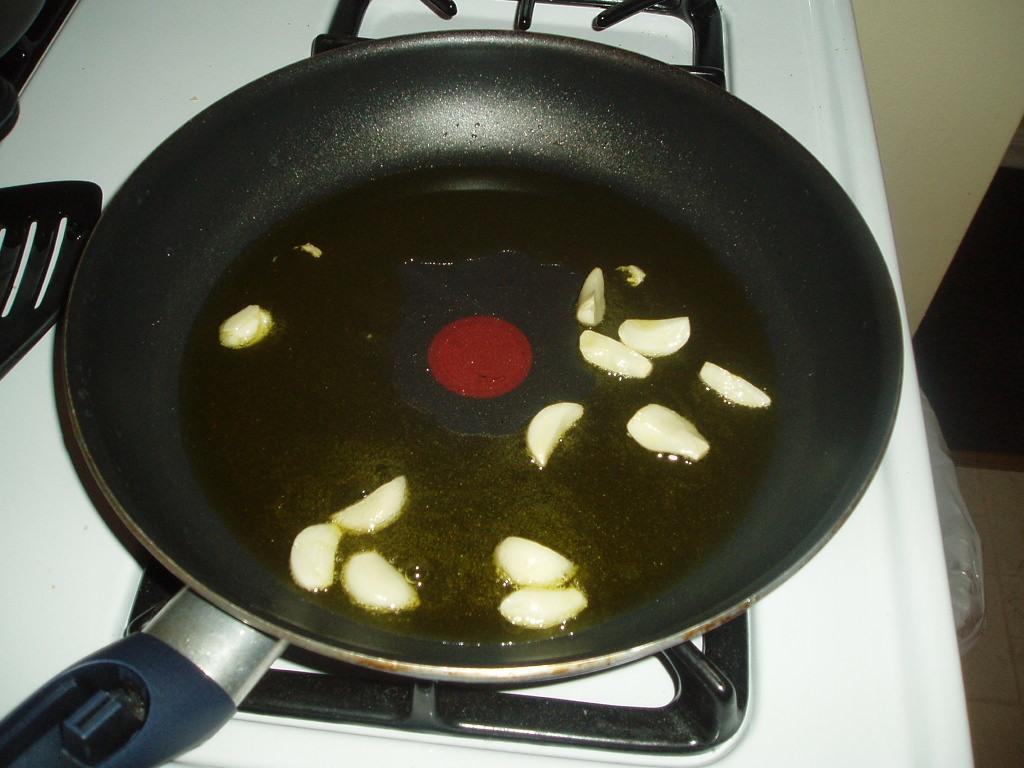Could you give a brief overview of what you see in this image? In this image we can see garlic pieces on a pan placed on the stove. 